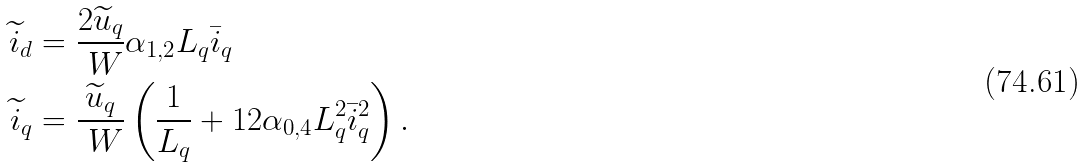Convert formula to latex. <formula><loc_0><loc_0><loc_500><loc_500>\widetilde { i } _ { d } & = \frac { 2 \widetilde { u } _ { q } } { \ W } \alpha _ { 1 , 2 } L _ { q } \bar { i } _ { q } \\ \widetilde { i } _ { q } & = \frac { \widetilde { u } _ { q } } { \ W } \left ( \frac { 1 } { L _ { q } } + 1 2 \alpha _ { 0 , 4 } L _ { q } ^ { 2 } \bar { i } _ { q } ^ { 2 } \right ) .</formula> 